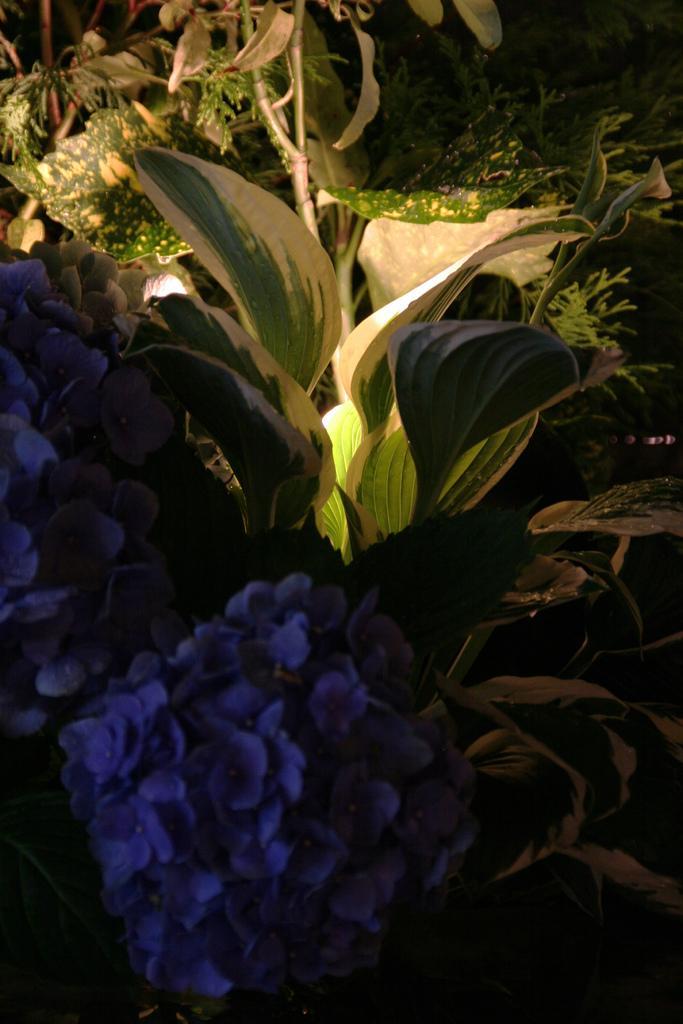Can you describe this image briefly? In this image there are flowers and plants. 